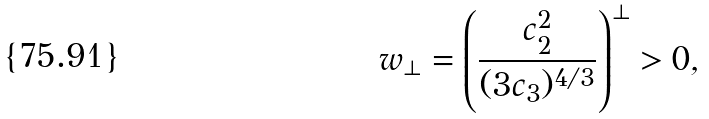<formula> <loc_0><loc_0><loc_500><loc_500>w _ { \perp } = \left ( \frac { c _ { 2 } ^ { 2 } } { ( 3 c _ { 3 } ) ^ { 4 / 3 } } \right ) ^ { \perp } > 0 ,</formula> 